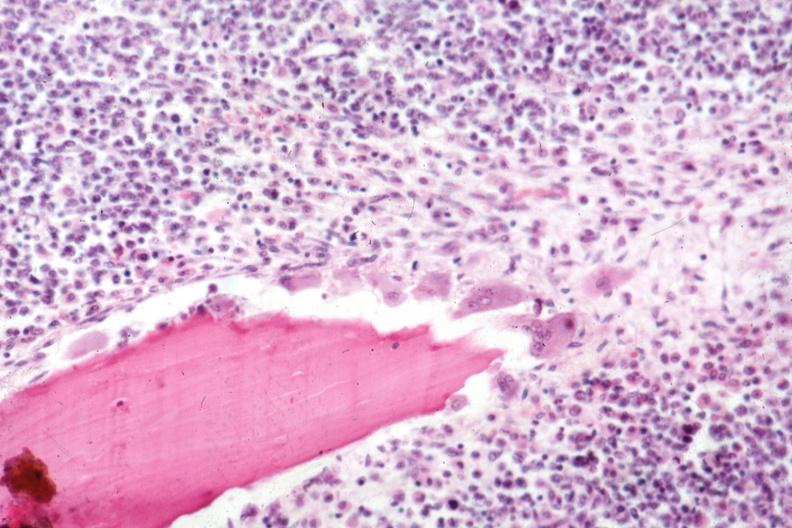what is present?
Answer the question using a single word or phrase. Joints 